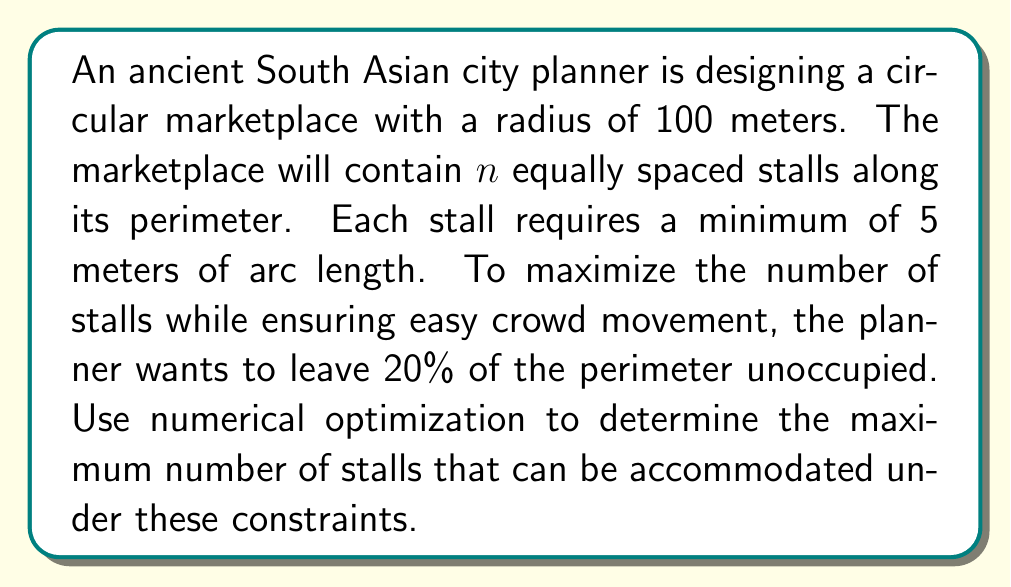Give your solution to this math problem. Let's approach this step-by-step:

1) First, we need to calculate the total circumference of the marketplace:
   $$C = 2\pi r = 2\pi(100) \approx 628.32\text{ meters}$$

2) We want 80% of this circumference to be occupied by stalls:
   $$\text{Available space} = 0.8C \approx 502.65\text{ meters}$$

3) Let $n$ be the number of stalls. Each stall needs at least 5 meters, so:
   $$\frac{502.65}{n} \geq 5$$

4) Solving for $n$:
   $$n \leq \frac{502.65}{5} \approx 100.53$$

5) Since $n$ must be an integer, the maximum value it can take is 100.

6) To verify, let's check if 100 stalls satisfy the 20% unoccupied constraint:
   $$\text{Space occupied} = 100 * 5 = 500\text{ meters}$$
   $$\text{Percentage occupied} = \frac{500}{628.32} * 100\% \approx 79.58\%$$

   This is less than 80%, so it satisfies our constraint.

7) We can confirm that 101 stalls would exceed the available space:
   $$101 * 5 = 505\text{ meters} > 502.65\text{ meters}$$

Therefore, the maximum number of stalls that can be accommodated is 100.
Answer: 100 stalls 